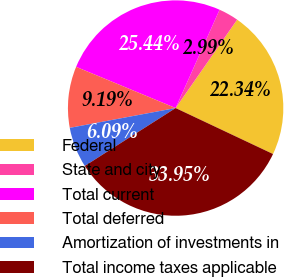Convert chart to OTSL. <chart><loc_0><loc_0><loc_500><loc_500><pie_chart><fcel>Federal<fcel>State and city<fcel>Total current<fcel>Total deferred<fcel>Amortization of investments in<fcel>Total income taxes applicable<nl><fcel>22.34%<fcel>2.99%<fcel>25.44%<fcel>9.19%<fcel>6.09%<fcel>33.95%<nl></chart> 